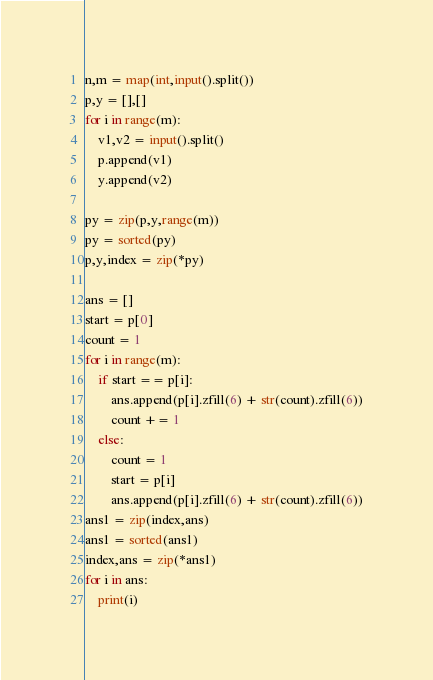<code> <loc_0><loc_0><loc_500><loc_500><_Python_>n,m = map(int,input().split())
p,y = [],[]
for i in range(m):
    v1,v2 = input().split()
    p.append(v1)
    y.append(v2)
    
py = zip(p,y,range(m))
py = sorted(py)
p,y,index = zip(*py)

ans = []
start = p[0]
count = 1
for i in range(m):
    if start == p[i]:
        ans.append(p[i].zfill(6) + str(count).zfill(6))
        count += 1
    else:
        count = 1
        start = p[i]
        ans.append(p[i].zfill(6) + str(count).zfill(6))
ans1 = zip(index,ans)
ans1 = sorted(ans1)
index,ans = zip(*ans1)
for i in ans:
    print(i)</code> 